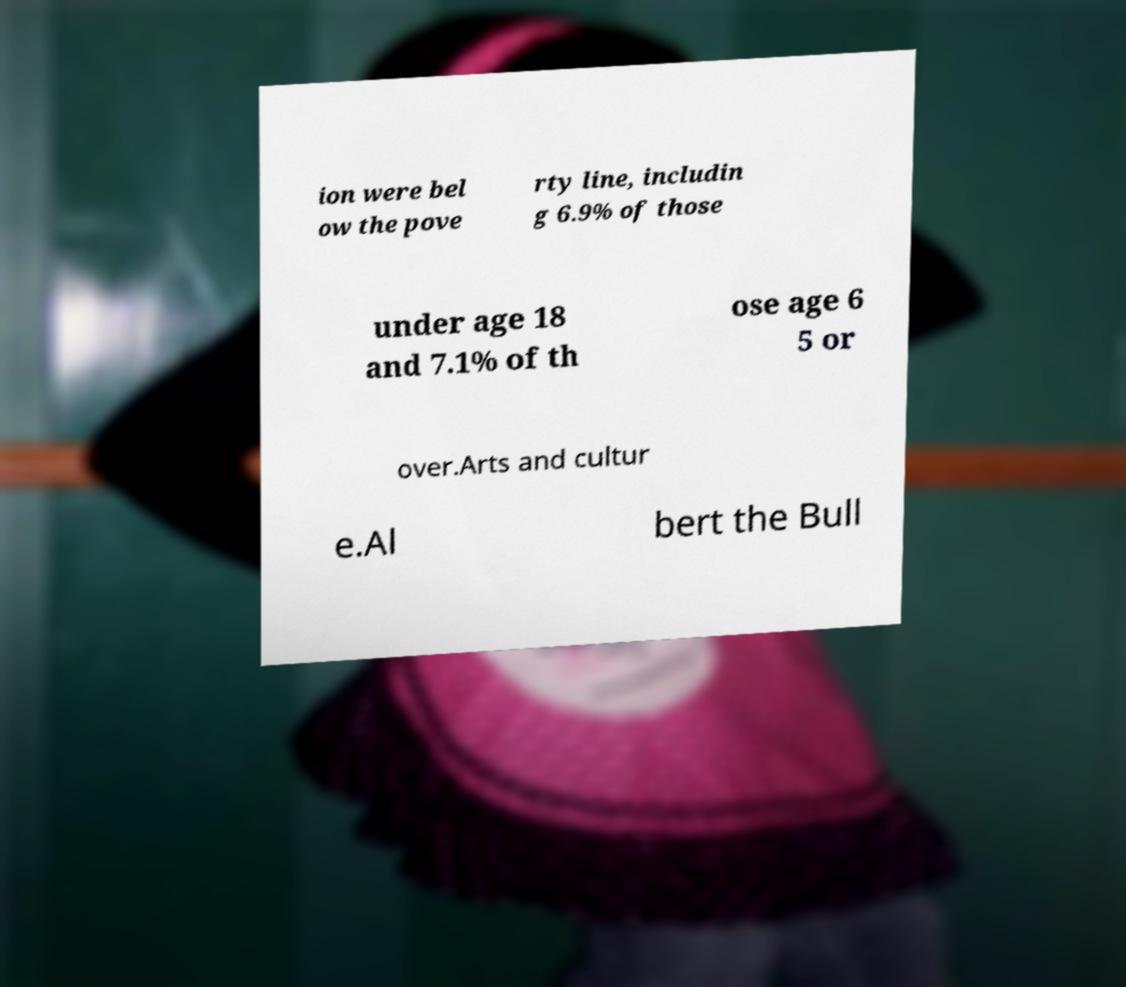For documentation purposes, I need the text within this image transcribed. Could you provide that? ion were bel ow the pove rty line, includin g 6.9% of those under age 18 and 7.1% of th ose age 6 5 or over.Arts and cultur e.Al bert the Bull 